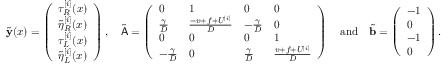Convert formula to latex. <formula><loc_0><loc_0><loc_500><loc_500>\tilde { y } ( x ) = \left ( \begin{array} { l } { \tau _ { R } ^ { [ i ] } ( x ) } \\ { \tilde { \eta } _ { R } ^ { [ i ] } ( x ) } \\ { \tau _ { L } ^ { [ i ] } ( x ) } \\ { \tilde { \eta } _ { L } ^ { [ i ] } ( x ) } \end{array} \right ) , \quad \tilde { A } = \left ( \begin{array} { l l l l } { 0 } & { 1 } & { 0 } & { 0 } \\ { \frac { \gamma } { D } } & { \frac { - v + f + U ^ { [ i ] } } { D } } & { - \frac { \gamma } { D } } & { 0 } \\ { 0 } & { 0 } & { 0 } & { 1 } \\ { - \frac { \gamma } { D } } & { 0 } & { \frac { \gamma } { D } } & { \frac { v + f + U ^ { [ i ] } } { D } } \end{array} \right ) \quad a n d \quad \tilde { b } = \left ( \begin{array} { l } { - 1 } \\ { 0 } \\ { - 1 } \\ { 0 } \end{array} \right ) .</formula> 